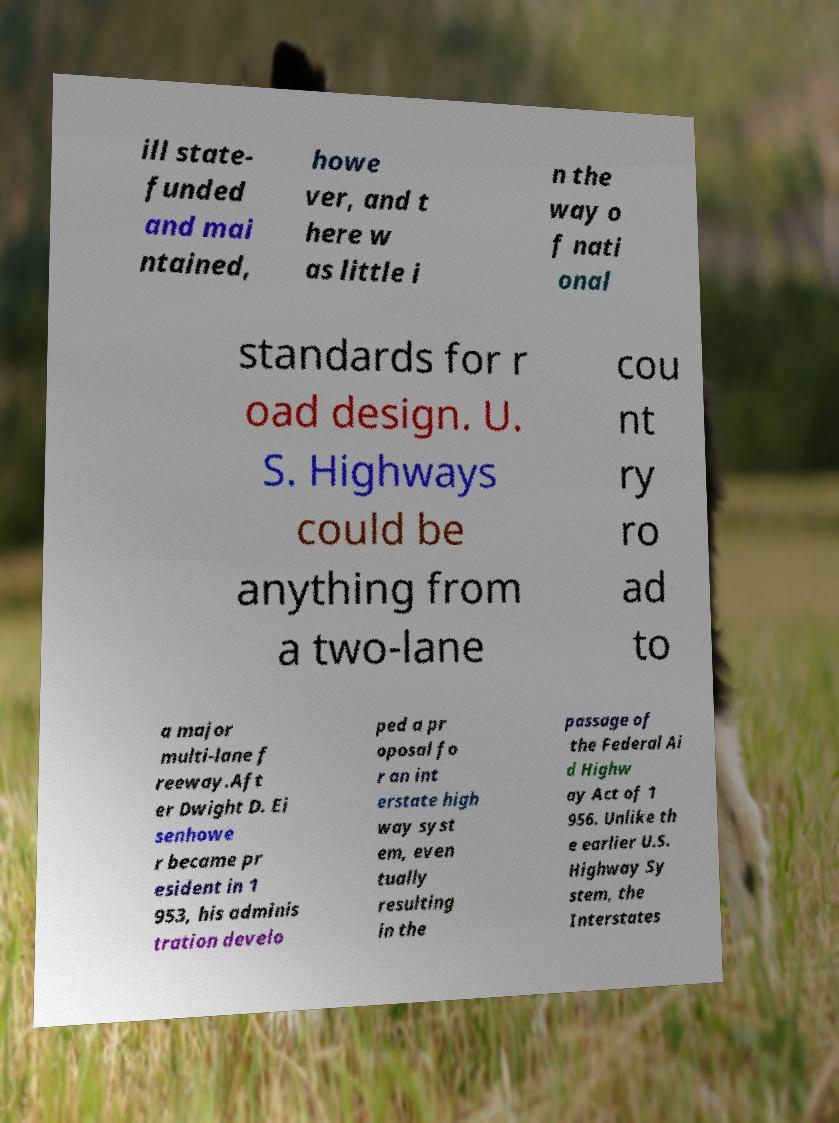Please read and relay the text visible in this image. What does it say? ill state- funded and mai ntained, howe ver, and t here w as little i n the way o f nati onal standards for r oad design. U. S. Highways could be anything from a two-lane cou nt ry ro ad to a major multi-lane f reeway.Aft er Dwight D. Ei senhowe r became pr esident in 1 953, his adminis tration develo ped a pr oposal fo r an int erstate high way syst em, even tually resulting in the passage of the Federal Ai d Highw ay Act of 1 956. Unlike th e earlier U.S. Highway Sy stem, the Interstates 